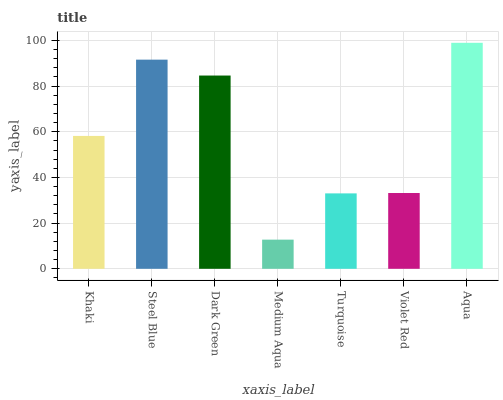Is Medium Aqua the minimum?
Answer yes or no. Yes. Is Aqua the maximum?
Answer yes or no. Yes. Is Steel Blue the minimum?
Answer yes or no. No. Is Steel Blue the maximum?
Answer yes or no. No. Is Steel Blue greater than Khaki?
Answer yes or no. Yes. Is Khaki less than Steel Blue?
Answer yes or no. Yes. Is Khaki greater than Steel Blue?
Answer yes or no. No. Is Steel Blue less than Khaki?
Answer yes or no. No. Is Khaki the high median?
Answer yes or no. Yes. Is Khaki the low median?
Answer yes or no. Yes. Is Violet Red the high median?
Answer yes or no. No. Is Aqua the low median?
Answer yes or no. No. 